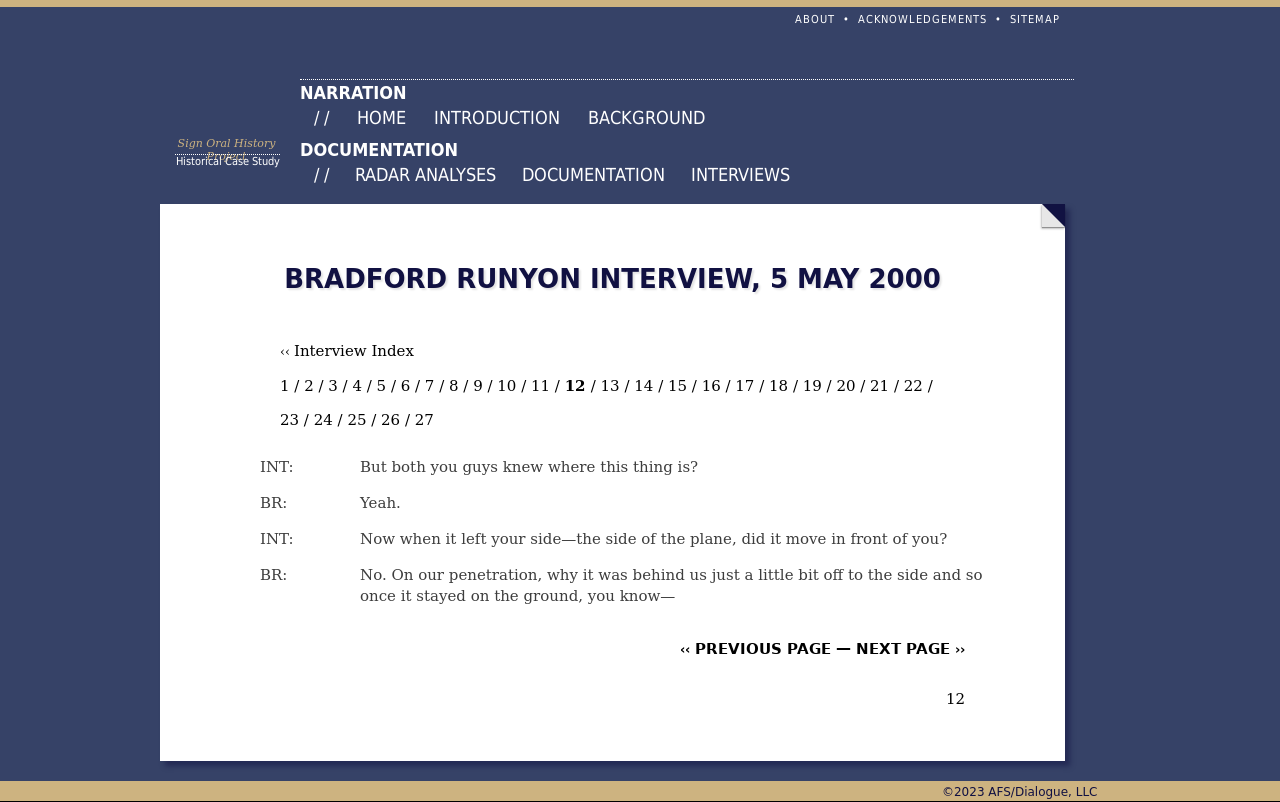What is the main topic of the interview shown in the image? The main topic of the interview displayed in the image appears to focus on a specific event or incident, as indicated by the detailed conversation that includes discussion about locations and events. The setting and date suggest it may involve a significant historical or investigative topic possibly related to a flight or military operation given the context clues like 'penetration' and positioning relative to an aircraft. 